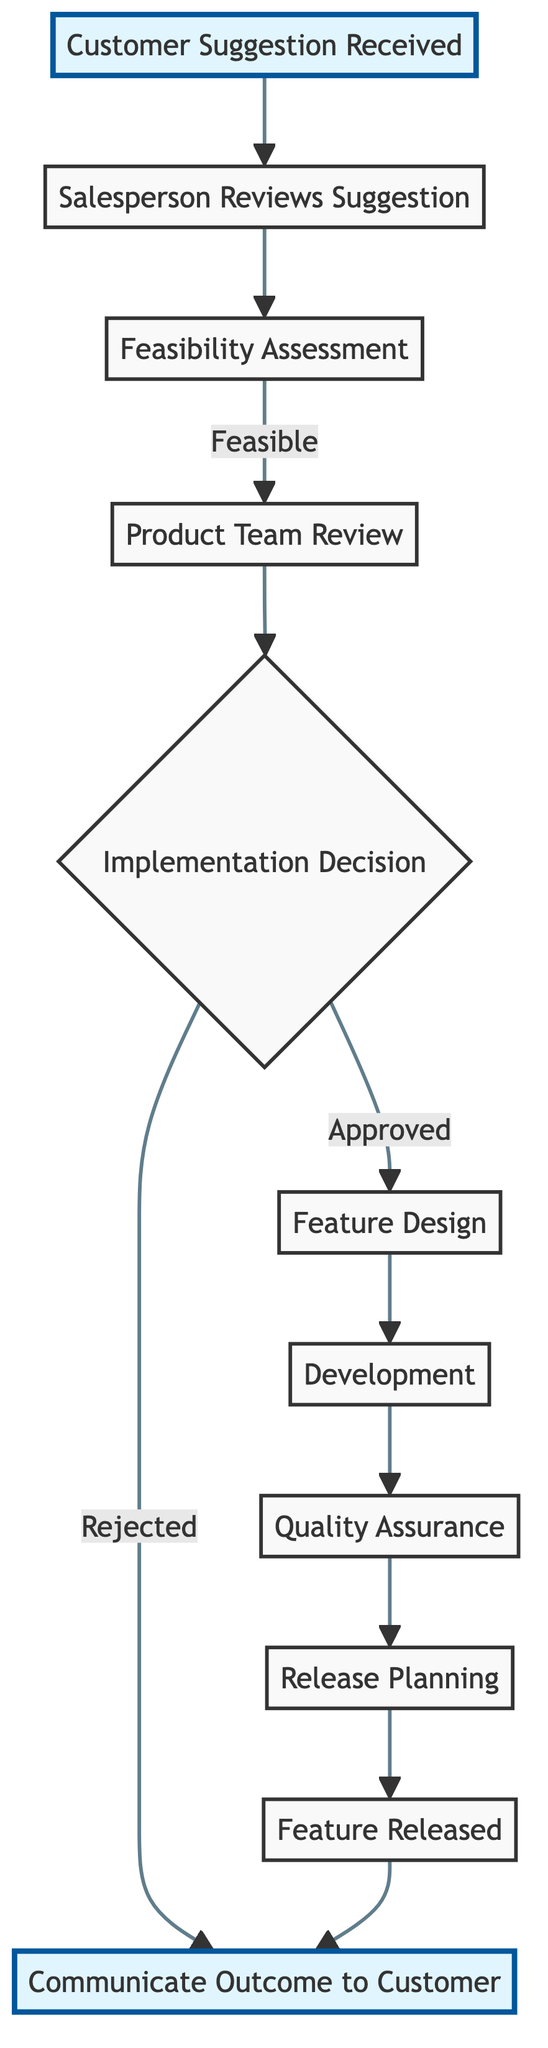What is the first step in the product feature request handling process? The first step is represented by the node labeled "Customer Suggestion Received," which indicates the initiation of the process upon receiving a suggestion from a customer.
Answer: Customer Suggestion Received How many nodes are there in this diagram? By counting each unique labeled node in the diagram, we see there are a total of 11 nodes listed.
Answer: 11 What label is assigned to the node that represents the step of evaluating the feasibility of a suggestion? The step of evaluating feasibility is indicated by the node labeled "Feasibility Assessment." This node is crucial in determining if the suggestion can be practically implemented.
Answer: Feasibility Assessment What decision follows the "Product Team Review"? The node that comes after "Product Team Review" is labeled "Implementation Decision," which signifies the point where a decision about implementing the feature is made.
Answer: Implementation Decision If a suggestion is rejected, what is the next step in the process? If a suggestion is rejected, the next step is communicated through the node labeled "Communicate Outcome to Customer," which indicates that the outcome of the decision is relayed back to the customer.
Answer: Communicate Outcome to Customer What is the last step before the feature is communicated to the customer after being released? The last step before communicating to the customer after the feature is released is represented by the node "Feature Released." This node indicates that the implementation process has concluded with the feature now active.
Answer: Feature Released How many edges are there in the directed graph? By counting the connections between nodes (edges) in the directed graph, we find there are 11 edges that depict the flow of the feature request process.
Answer: 11 Which node indicates the step where the feature is actively being developed? The step of actively developing the feature is indicated by the node labeled "Development," which follows the feature design stage.
Answer: Development What does the node "Quality Assurance" represent in the process? The node "Quality Assurance" represents the stage where the new feature undergoes testing and validation procedures to ensure it meets quality standards before its release.
Answer: Quality Assurance In which step is an approved feature designed? The design of an approved feature occurs at the node labeled "Feature Design," which follows the implementation decision if the suggestion is approved.
Answer: Feature Design 